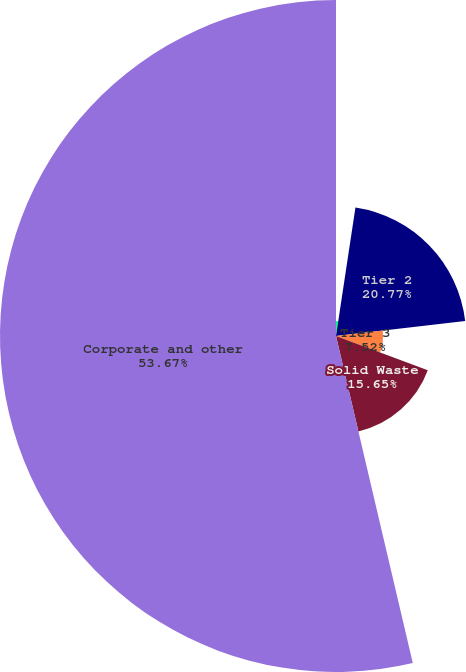<chart> <loc_0><loc_0><loc_500><loc_500><pie_chart><fcel>Tier 1<fcel>Tier 2<fcel>Tier 3<fcel>Solid Waste<fcel>Corporate and other<nl><fcel>2.39%<fcel>20.77%<fcel>7.52%<fcel>15.65%<fcel>53.67%<nl></chart> 